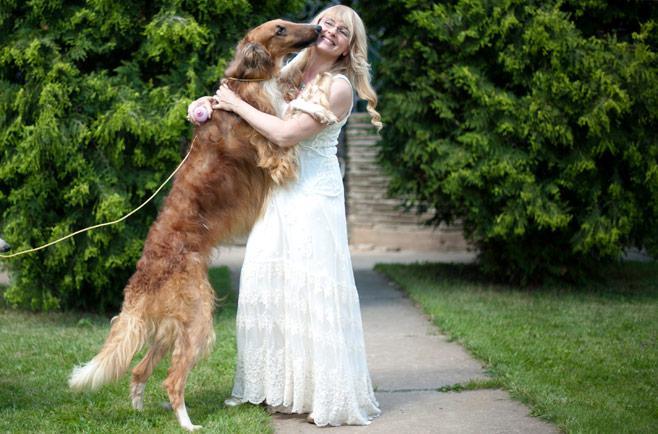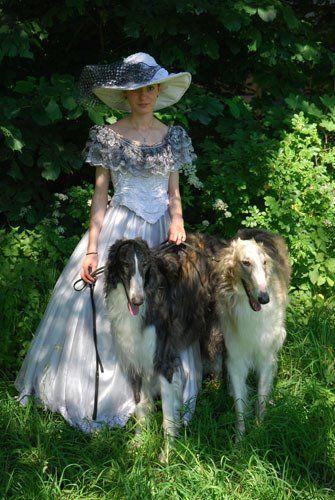The first image is the image on the left, the second image is the image on the right. Considering the images on both sides, is "There are two women, and each has at least one dog." valid? Answer yes or no. Yes. The first image is the image on the left, the second image is the image on the right. For the images displayed, is the sentence "One of the photos shows two dogs and no people." factually correct? Answer yes or no. No. 